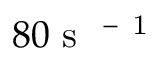Convert formula to latex. <formula><loc_0><loc_0><loc_500><loc_500>8 0 { s } ^ { - 1 }</formula> 